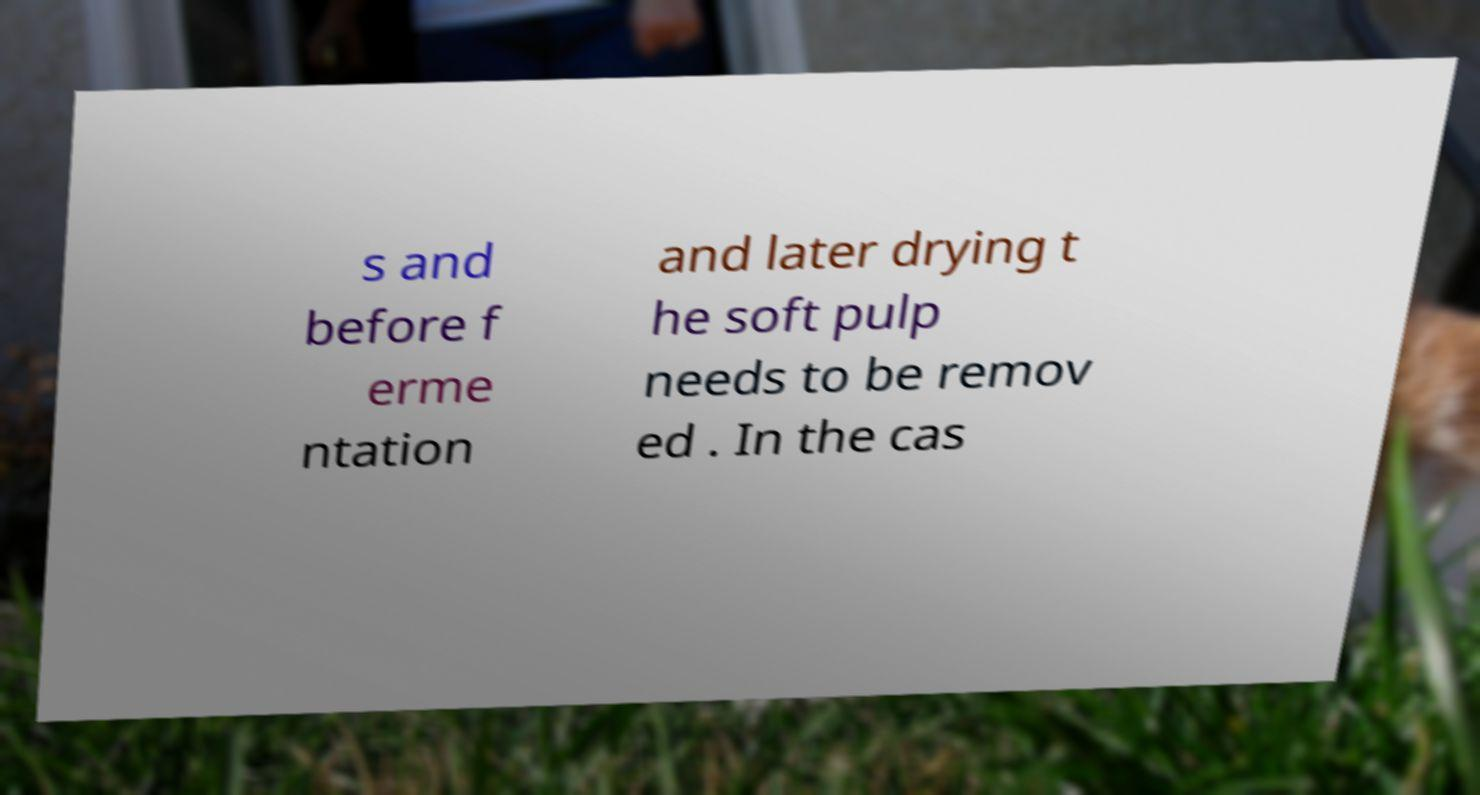I need the written content from this picture converted into text. Can you do that? s and before f erme ntation and later drying t he soft pulp needs to be remov ed . In the cas 